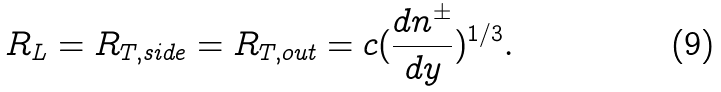<formula> <loc_0><loc_0><loc_500><loc_500>R _ { L } = R _ { T , s i d e } = R _ { T , o u t } = c ( { \frac { d n ^ { \pm } } { d y } } ) ^ { 1 / 3 } .</formula> 